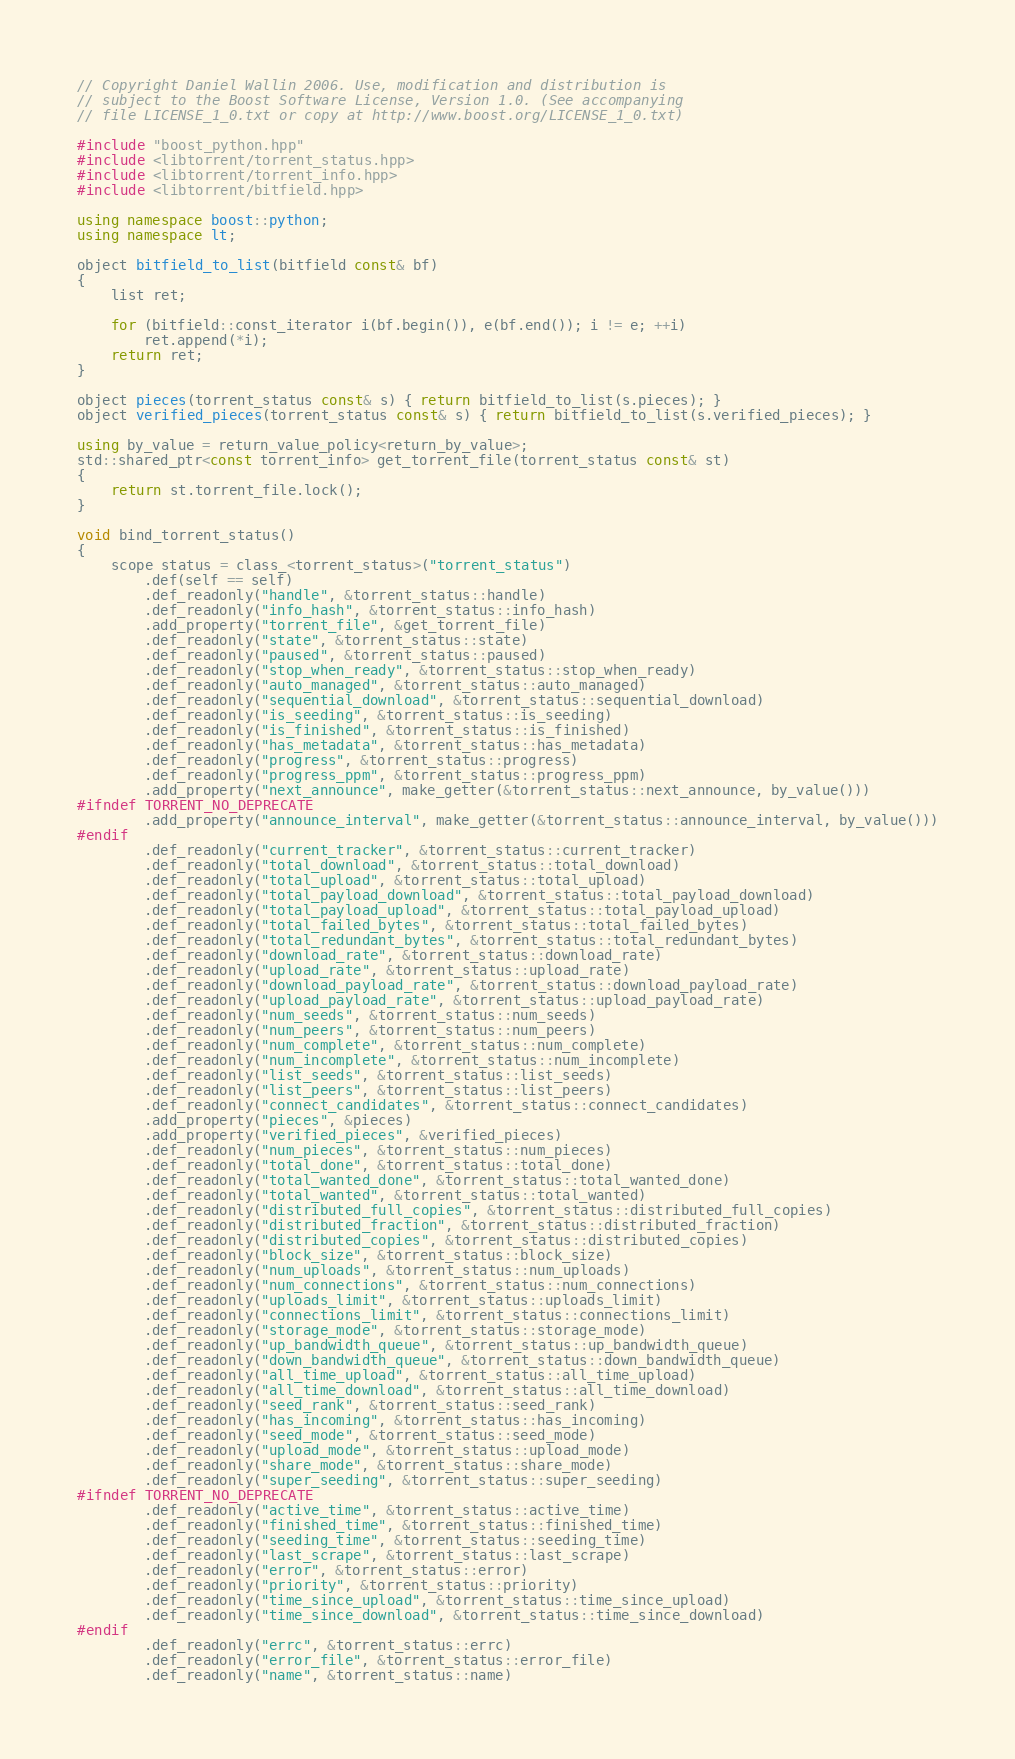Convert code to text. <code><loc_0><loc_0><loc_500><loc_500><_C++_>// Copyright Daniel Wallin 2006. Use, modification and distribution is
// subject to the Boost Software License, Version 1.0. (See accompanying
// file LICENSE_1_0.txt or copy at http://www.boost.org/LICENSE_1_0.txt)

#include "boost_python.hpp"
#include <libtorrent/torrent_status.hpp>
#include <libtorrent/torrent_info.hpp>
#include <libtorrent/bitfield.hpp>

using namespace boost::python;
using namespace lt;

object bitfield_to_list(bitfield const& bf)
{
	list ret;

	for (bitfield::const_iterator i(bf.begin()), e(bf.end()); i != e; ++i)
		ret.append(*i);
	return ret;
}

object pieces(torrent_status const& s) { return bitfield_to_list(s.pieces); }
object verified_pieces(torrent_status const& s) { return bitfield_to_list(s.verified_pieces); }

using by_value = return_value_policy<return_by_value>;
std::shared_ptr<const torrent_info> get_torrent_file(torrent_status const& st)
{
	return st.torrent_file.lock();
}

void bind_torrent_status()
{
    scope status = class_<torrent_status>("torrent_status")
        .def(self == self)
        .def_readonly("handle", &torrent_status::handle)
        .def_readonly("info_hash", &torrent_status::info_hash)
        .add_property("torrent_file", &get_torrent_file)
        .def_readonly("state", &torrent_status::state)
        .def_readonly("paused", &torrent_status::paused)
        .def_readonly("stop_when_ready", &torrent_status::stop_when_ready)
        .def_readonly("auto_managed", &torrent_status::auto_managed)
        .def_readonly("sequential_download", &torrent_status::sequential_download)
        .def_readonly("is_seeding", &torrent_status::is_seeding)
        .def_readonly("is_finished", &torrent_status::is_finished)
        .def_readonly("has_metadata", &torrent_status::has_metadata)
        .def_readonly("progress", &torrent_status::progress)
        .def_readonly("progress_ppm", &torrent_status::progress_ppm)
        .add_property("next_announce", make_getter(&torrent_status::next_announce, by_value()))
#ifndef TORRENT_NO_DEPRECATE
        .add_property("announce_interval", make_getter(&torrent_status::announce_interval, by_value()))
#endif
        .def_readonly("current_tracker", &torrent_status::current_tracker)
        .def_readonly("total_download", &torrent_status::total_download)
        .def_readonly("total_upload", &torrent_status::total_upload)
        .def_readonly("total_payload_download", &torrent_status::total_payload_download)
        .def_readonly("total_payload_upload", &torrent_status::total_payload_upload)
        .def_readonly("total_failed_bytes", &torrent_status::total_failed_bytes)
        .def_readonly("total_redundant_bytes", &torrent_status::total_redundant_bytes)
        .def_readonly("download_rate", &torrent_status::download_rate)
        .def_readonly("upload_rate", &torrent_status::upload_rate)
        .def_readonly("download_payload_rate", &torrent_status::download_payload_rate)
        .def_readonly("upload_payload_rate", &torrent_status::upload_payload_rate)
        .def_readonly("num_seeds", &torrent_status::num_seeds)
        .def_readonly("num_peers", &torrent_status::num_peers)
        .def_readonly("num_complete", &torrent_status::num_complete)
        .def_readonly("num_incomplete", &torrent_status::num_incomplete)
        .def_readonly("list_seeds", &torrent_status::list_seeds)
        .def_readonly("list_peers", &torrent_status::list_peers)
        .def_readonly("connect_candidates", &torrent_status::connect_candidates)
        .add_property("pieces", &pieces)
        .add_property("verified_pieces", &verified_pieces)
        .def_readonly("num_pieces", &torrent_status::num_pieces)
        .def_readonly("total_done", &torrent_status::total_done)
        .def_readonly("total_wanted_done", &torrent_status::total_wanted_done)
        .def_readonly("total_wanted", &torrent_status::total_wanted)
        .def_readonly("distributed_full_copies", &torrent_status::distributed_full_copies)
        .def_readonly("distributed_fraction", &torrent_status::distributed_fraction)
        .def_readonly("distributed_copies", &torrent_status::distributed_copies)
        .def_readonly("block_size", &torrent_status::block_size)
        .def_readonly("num_uploads", &torrent_status::num_uploads)
        .def_readonly("num_connections", &torrent_status::num_connections)
        .def_readonly("uploads_limit", &torrent_status::uploads_limit)
        .def_readonly("connections_limit", &torrent_status::connections_limit)
        .def_readonly("storage_mode", &torrent_status::storage_mode)
        .def_readonly("up_bandwidth_queue", &torrent_status::up_bandwidth_queue)
        .def_readonly("down_bandwidth_queue", &torrent_status::down_bandwidth_queue)
        .def_readonly("all_time_upload", &torrent_status::all_time_upload)
        .def_readonly("all_time_download", &torrent_status::all_time_download)
        .def_readonly("seed_rank", &torrent_status::seed_rank)
        .def_readonly("has_incoming", &torrent_status::has_incoming)
        .def_readonly("seed_mode", &torrent_status::seed_mode)
        .def_readonly("upload_mode", &torrent_status::upload_mode)
        .def_readonly("share_mode", &torrent_status::share_mode)
        .def_readonly("super_seeding", &torrent_status::super_seeding)
#ifndef TORRENT_NO_DEPRECATE
        .def_readonly("active_time", &torrent_status::active_time)
        .def_readonly("finished_time", &torrent_status::finished_time)
        .def_readonly("seeding_time", &torrent_status::seeding_time)
        .def_readonly("last_scrape", &torrent_status::last_scrape)
        .def_readonly("error", &torrent_status::error)
        .def_readonly("priority", &torrent_status::priority)
        .def_readonly("time_since_upload", &torrent_status::time_since_upload)
        .def_readonly("time_since_download", &torrent_status::time_since_download)
#endif
        .def_readonly("errc", &torrent_status::errc)
        .def_readonly("error_file", &torrent_status::error_file)
        .def_readonly("name", &torrent_status::name)</code> 